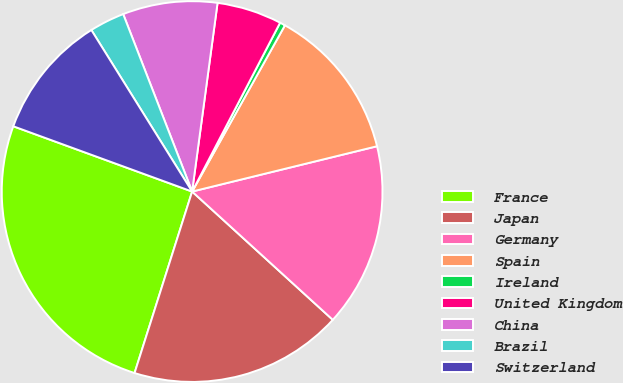Convert chart. <chart><loc_0><loc_0><loc_500><loc_500><pie_chart><fcel>France<fcel>Japan<fcel>Germany<fcel>Spain<fcel>Ireland<fcel>United Kingdom<fcel>China<fcel>Brazil<fcel>Switzerland<nl><fcel>25.68%<fcel>18.12%<fcel>15.59%<fcel>13.07%<fcel>0.46%<fcel>5.51%<fcel>8.03%<fcel>2.98%<fcel>10.55%<nl></chart> 